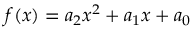Convert formula to latex. <formula><loc_0><loc_0><loc_500><loc_500>f ( x ) = a _ { 2 } x ^ { 2 } + a _ { 1 } x + a _ { 0 }</formula> 